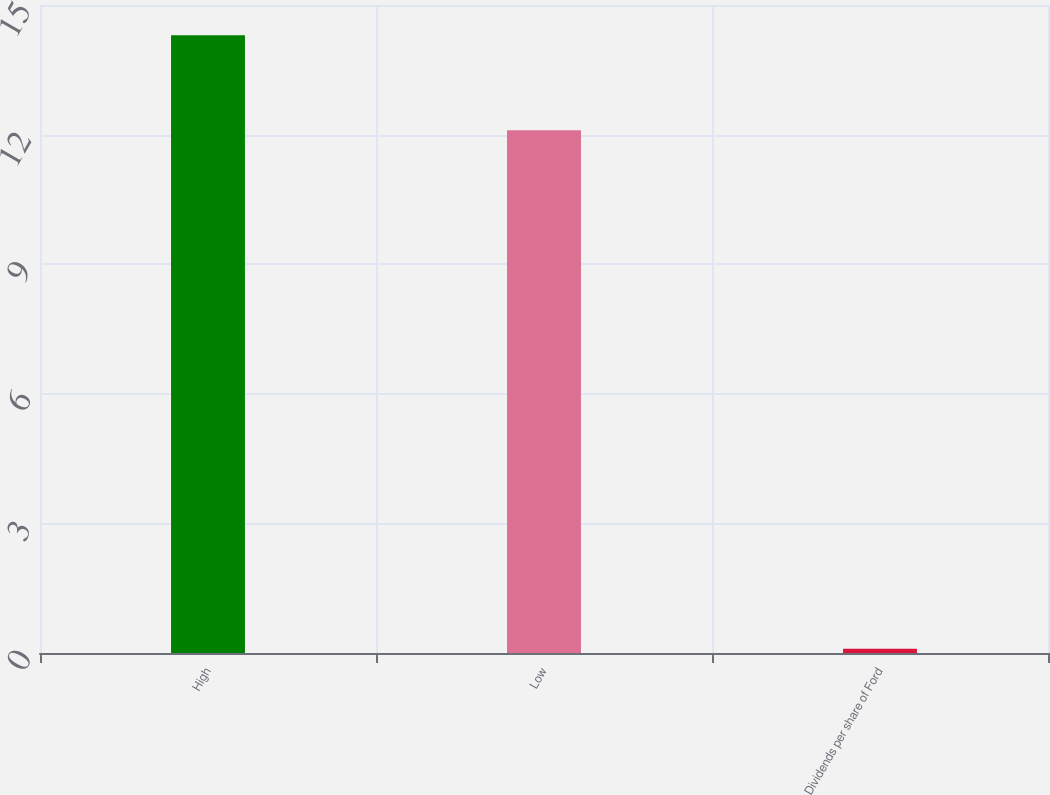Convert chart to OTSL. <chart><loc_0><loc_0><loc_500><loc_500><bar_chart><fcel>High<fcel>Low<fcel>Dividends per share of Ford<nl><fcel>14.3<fcel>12.1<fcel>0.1<nl></chart> 